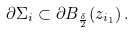<formula> <loc_0><loc_0><loc_500><loc_500>\partial \Sigma _ { i } \subset \partial B _ { \frac { \delta } { 2 } } ( z _ { i _ { 1 } } ) \, .</formula> 